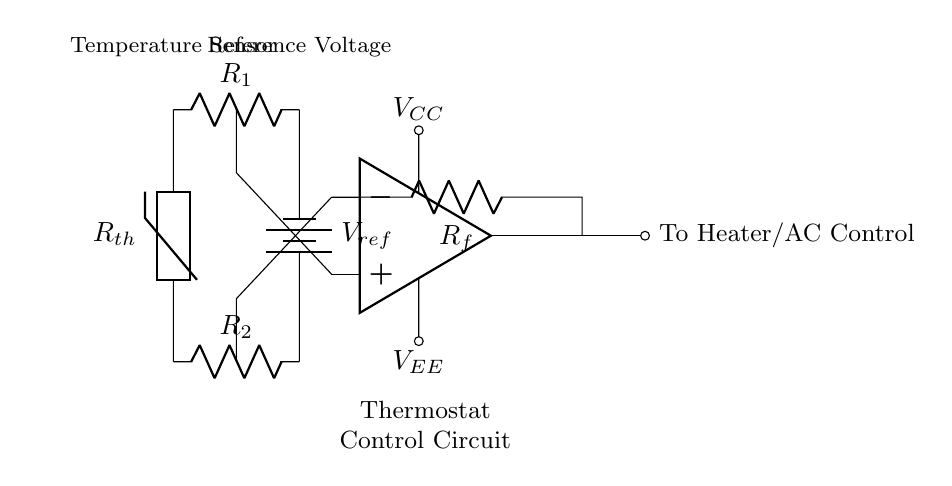What type of sensor is used in this circuit? The circuit uses a thermistor as a temperature sensor, indicated by the symbol labeled Rth.
Answer: thermistor What is the purpose of the operational amplifier in this circuit? The operational amplifier amplifies the difference in voltage between its two input terminals, which helps in precise temperature control by comparing the sensor output and the reference voltage.
Answer: amplification What is the reference voltage labeled as in this diagram? The reference voltage in the circuit is labeled as Vref, which is connected to the inverting input of the operational amplifier.
Answer: Vref What component is connected to the output of the operational amplifier? The output of the operational amplifier is connected to a load labeled as "To Heater/AC Control," which indicates it regulates heating or cooling.
Answer: To Heater/AC Control What are the resistor values used for in this circuit? The resistors R1 and R2 form a voltage divider to stabilize the input voltage from the thermistor before it reaches the operational amplifier's inputs; Rf provides feedback for gain control.
Answer: voltage divider 